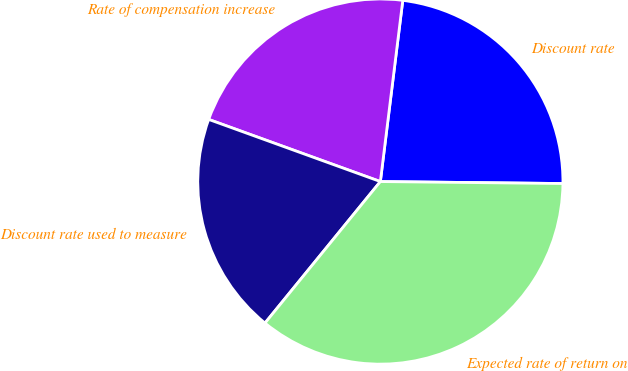Convert chart to OTSL. <chart><loc_0><loc_0><loc_500><loc_500><pie_chart><fcel>Discount rate<fcel>Rate of compensation increase<fcel>Discount rate used to measure<fcel>Expected rate of return on<nl><fcel>23.21%<fcel>21.43%<fcel>19.64%<fcel>35.71%<nl></chart> 